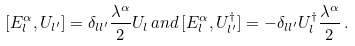<formula> <loc_0><loc_0><loc_500><loc_500>[ E _ { l } ^ { \alpha } , U _ { l ^ { \prime } } ] = \delta _ { l { l ^ { \prime } } } \frac { \lambda ^ { \alpha } } { 2 } U _ { l } \, a n d \, [ E _ { l } ^ { \alpha } , U _ { l ^ { \prime } } ^ { \dagger } ] = - \delta _ { l { l ^ { \prime } } } U _ { l } ^ { \dagger } \frac { \lambda ^ { \alpha } } { 2 } \, .</formula> 